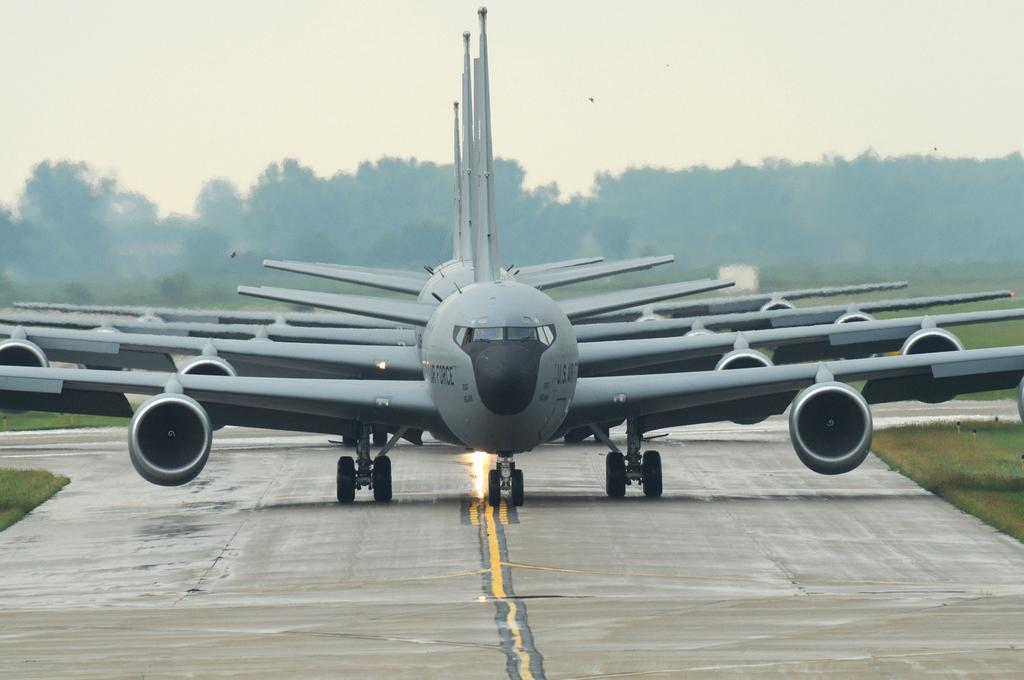Can you describe this image briefly? In the middle of the image we can see some planes. Behind the planes there is grass and trees and sky. 